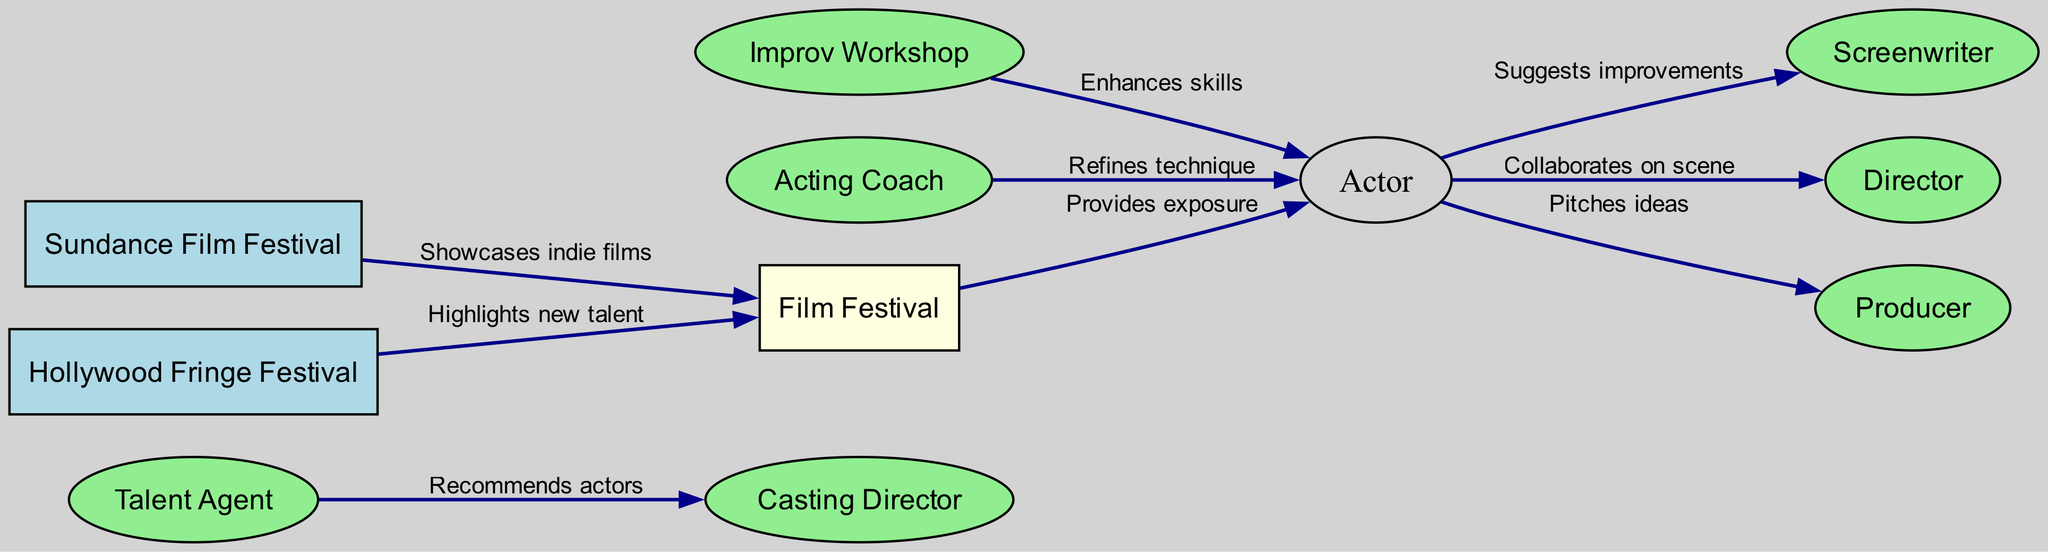What are the total number of nodes in the diagram? The diagram contains a list of unique entities or positions represented by nodes. By counting each of the nodes listed, we find that there are 10 distinct nodes present.
Answer: 10 Which entity is connected to both the Actor and the Producer? The edges show relationships, and by inspecting the diagram, we identify that the Actor has a direct connection to both the Screenwriter and the Producer. So, the intermediary role connecting these parties is the Actor.
Answer: Actor What is the relationship that connects the Talent Agent and the Casting Director? The edge between the Talent Agent and Casting Director defines the relationship, indicating that the Talent Agent recommends actors to the Casting Director. This is specified in the label of the edge connecting these two nodes.
Answer: Recommends actors Which workshops enhance the skills of the Actor? By looking at the connections, we see that the Improv Workshop has a direct edge leading to the Actor with the label indicating it enhances their skills. This is the only workshop listed in the diagram that has a direct association with the Actor.
Answer: Improv Workshop How many collaborations are shown involving the Actor? The Actor is involved in multiple edges, specifically with the Screenwriter and Director for suggestions and collaborations. By counting the edges directly connected to the Actor, we find three collaborations represented.
Answer: 3 What is the primary function of the Film Festival in regards to actors? Examining the edge connected to the Actor, we find the Film Festival provides exposure, which indicates its role in helping actors gain visibility within the industry.
Answer: Provides exposure What two film festivals are noted in the diagram? The nodes relevant to film festivals in the diagram are Sundance Film Festival and Hollywood Fringe Festival, both of which emphasize the showcase of films and talent within the industry.
Answer: Sundance Film Festival, Hollywood Fringe Festival How does the Acting Coach interact with the Actor? The edge between the Acting Coach and Actor specifically states that the Acting Coach refines the Actor's technique, showcasing a direct mentorship relationship.
Answer: Refines technique 